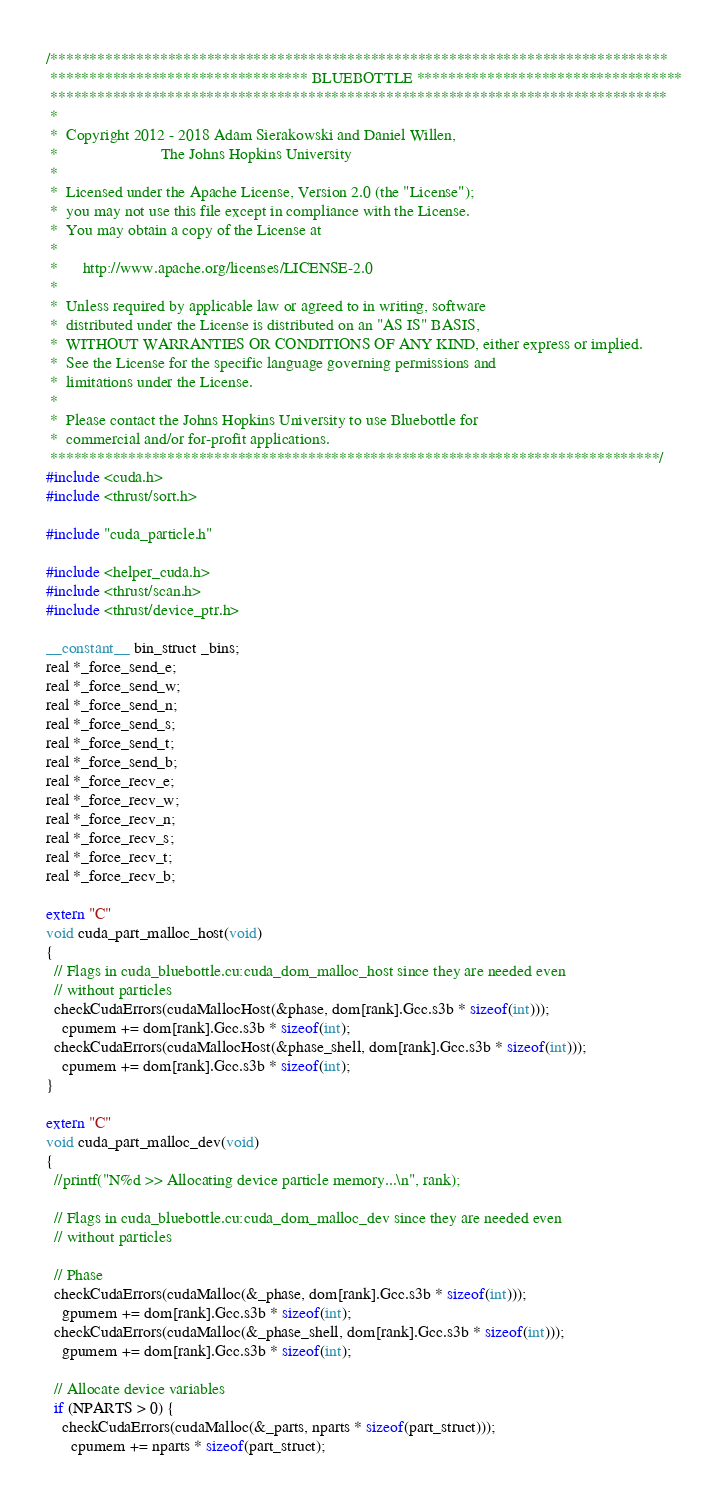Convert code to text. <code><loc_0><loc_0><loc_500><loc_500><_Cuda_>/*******************************************************************************
 ********************************* BLUEBOTTLE **********************************
 *******************************************************************************
 *
 *  Copyright 2012 - 2018 Adam Sierakowski and Daniel Willen, 
 *                         The Johns Hopkins University
 *
 *  Licensed under the Apache License, Version 2.0 (the "License");
 *  you may not use this file except in compliance with the License.
 *  You may obtain a copy of the License at
 *
 *      http://www.apache.org/licenses/LICENSE-2.0
 *
 *  Unless required by applicable law or agreed to in writing, software
 *  distributed under the License is distributed on an "AS IS" BASIS,
 *  WITHOUT WARRANTIES OR CONDITIONS OF ANY KIND, either express or implied.
 *  See the License for the specific language governing permissions and
 *  limitations under the License.
 *
 *  Please contact the Johns Hopkins University to use Bluebottle for
 *  commercial and/or for-profit applications.
 ******************************************************************************/
#include <cuda.h>
#include <thrust/sort.h>

#include "cuda_particle.h"

#include <helper_cuda.h>
#include <thrust/scan.h>
#include <thrust/device_ptr.h>

__constant__ bin_struct _bins;
real *_force_send_e;
real *_force_send_w;
real *_force_send_n;
real *_force_send_s;
real *_force_send_t;
real *_force_send_b;
real *_force_recv_e;
real *_force_recv_w;
real *_force_recv_n;
real *_force_recv_s;
real *_force_recv_t;
real *_force_recv_b;

extern "C"
void cuda_part_malloc_host(void)
{
  // Flags in cuda_bluebottle.cu:cuda_dom_malloc_host since they are needed even
  // without particles
  checkCudaErrors(cudaMallocHost(&phase, dom[rank].Gcc.s3b * sizeof(int)));
    cpumem += dom[rank].Gcc.s3b * sizeof(int);
  checkCudaErrors(cudaMallocHost(&phase_shell, dom[rank].Gcc.s3b * sizeof(int)));
    cpumem += dom[rank].Gcc.s3b * sizeof(int);
}

extern "C"
void cuda_part_malloc_dev(void)
{
  //printf("N%d >> Allocating device particle memory...\n", rank);

  // Flags in cuda_bluebottle.cu:cuda_dom_malloc_dev since they are needed even
  // without particles

  // Phase
  checkCudaErrors(cudaMalloc(&_phase, dom[rank].Gcc.s3b * sizeof(int)));
    gpumem += dom[rank].Gcc.s3b * sizeof(int);
  checkCudaErrors(cudaMalloc(&_phase_shell, dom[rank].Gcc.s3b * sizeof(int)));
    gpumem += dom[rank].Gcc.s3b * sizeof(int);

  // Allocate device variables
  if (NPARTS > 0) {
    checkCudaErrors(cudaMalloc(&_parts, nparts * sizeof(part_struct)));
      cpumem += nparts * sizeof(part_struct);</code> 